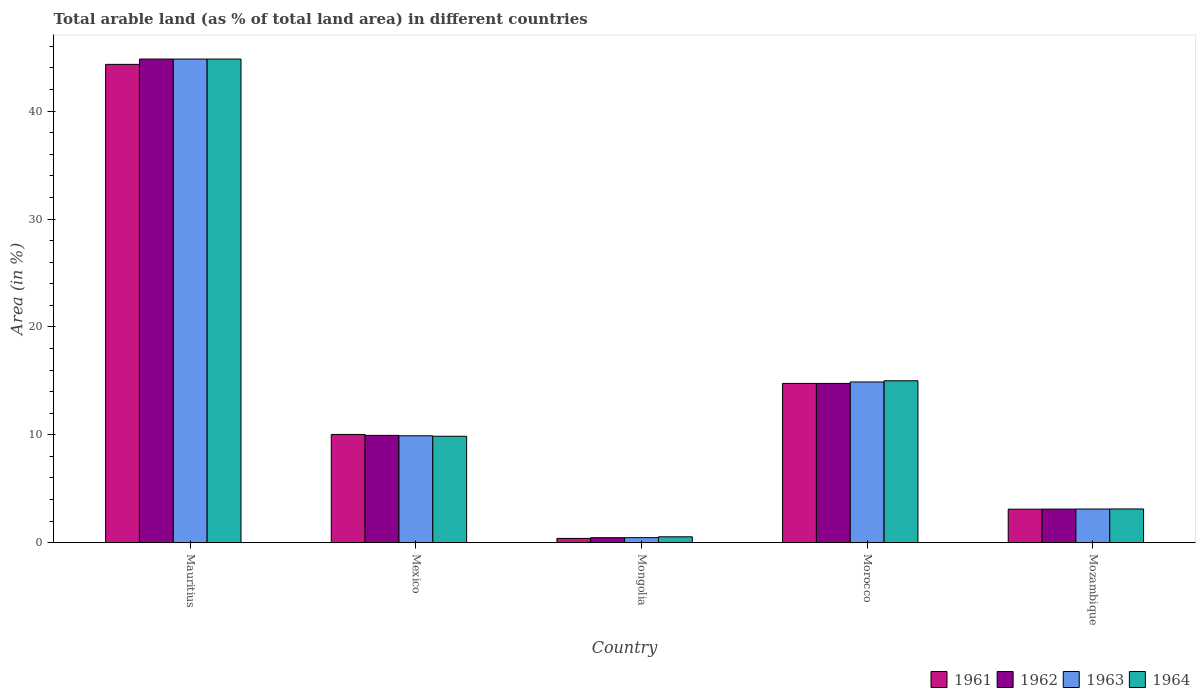Are the number of bars per tick equal to the number of legend labels?
Your answer should be compact. Yes. How many bars are there on the 1st tick from the left?
Offer a terse response. 4. What is the label of the 4th group of bars from the left?
Offer a very short reply. Morocco. What is the percentage of arable land in 1963 in Morocco?
Your answer should be compact. 14.9. Across all countries, what is the maximum percentage of arable land in 1964?
Keep it short and to the point. 44.83. Across all countries, what is the minimum percentage of arable land in 1963?
Offer a very short reply. 0.47. In which country was the percentage of arable land in 1964 maximum?
Give a very brief answer. Mauritius. In which country was the percentage of arable land in 1963 minimum?
Offer a very short reply. Mongolia. What is the total percentage of arable land in 1964 in the graph?
Offer a terse response. 73.38. What is the difference between the percentage of arable land in 1963 in Morocco and that in Mozambique?
Provide a succinct answer. 11.78. What is the difference between the percentage of arable land in 1964 in Mongolia and the percentage of arable land in 1963 in Mauritius?
Give a very brief answer. -44.28. What is the average percentage of arable land in 1962 per country?
Your answer should be compact. 14.62. What is the difference between the percentage of arable land of/in 1961 and percentage of arable land of/in 1962 in Mauritius?
Your response must be concise. -0.49. In how many countries, is the percentage of arable land in 1963 greater than 20 %?
Provide a succinct answer. 1. What is the ratio of the percentage of arable land in 1963 in Mongolia to that in Mozambique?
Provide a short and direct response. 0.15. Is the percentage of arable land in 1961 in Mongolia less than that in Morocco?
Ensure brevity in your answer.  Yes. What is the difference between the highest and the second highest percentage of arable land in 1961?
Offer a terse response. -34.3. What is the difference between the highest and the lowest percentage of arable land in 1961?
Your response must be concise. 43.93. In how many countries, is the percentage of arable land in 1962 greater than the average percentage of arable land in 1962 taken over all countries?
Make the answer very short. 2. What does the 2nd bar from the right in Mexico represents?
Provide a succinct answer. 1963. Is it the case that in every country, the sum of the percentage of arable land in 1963 and percentage of arable land in 1962 is greater than the percentage of arable land in 1964?
Ensure brevity in your answer.  Yes. What is the difference between two consecutive major ticks on the Y-axis?
Your answer should be compact. 10. Does the graph contain grids?
Your response must be concise. No. Where does the legend appear in the graph?
Keep it short and to the point. Bottom right. How many legend labels are there?
Offer a very short reply. 4. How are the legend labels stacked?
Give a very brief answer. Horizontal. What is the title of the graph?
Offer a terse response. Total arable land (as % of total land area) in different countries. What is the label or title of the X-axis?
Give a very brief answer. Country. What is the label or title of the Y-axis?
Your answer should be very brief. Area (in %). What is the Area (in %) in 1961 in Mauritius?
Ensure brevity in your answer.  44.33. What is the Area (in %) in 1962 in Mauritius?
Keep it short and to the point. 44.83. What is the Area (in %) in 1963 in Mauritius?
Provide a short and direct response. 44.83. What is the Area (in %) in 1964 in Mauritius?
Ensure brevity in your answer.  44.83. What is the Area (in %) of 1961 in Mexico?
Provide a short and direct response. 10.03. What is the Area (in %) of 1962 in Mexico?
Provide a succinct answer. 9.95. What is the Area (in %) of 1963 in Mexico?
Offer a terse response. 9.91. What is the Area (in %) of 1964 in Mexico?
Your answer should be compact. 9.87. What is the Area (in %) in 1961 in Mongolia?
Keep it short and to the point. 0.4. What is the Area (in %) of 1962 in Mongolia?
Make the answer very short. 0.47. What is the Area (in %) of 1963 in Mongolia?
Provide a succinct answer. 0.47. What is the Area (in %) of 1964 in Mongolia?
Offer a terse response. 0.55. What is the Area (in %) of 1961 in Morocco?
Give a very brief answer. 14.76. What is the Area (in %) in 1962 in Morocco?
Your answer should be compact. 14.76. What is the Area (in %) of 1963 in Morocco?
Offer a terse response. 14.9. What is the Area (in %) of 1964 in Morocco?
Your answer should be very brief. 15.01. What is the Area (in %) in 1961 in Mozambique?
Your response must be concise. 3.11. What is the Area (in %) of 1962 in Mozambique?
Your answer should be compact. 3.12. What is the Area (in %) of 1963 in Mozambique?
Provide a succinct answer. 3.12. What is the Area (in %) in 1964 in Mozambique?
Provide a short and direct response. 3.13. Across all countries, what is the maximum Area (in %) of 1961?
Your answer should be compact. 44.33. Across all countries, what is the maximum Area (in %) of 1962?
Provide a short and direct response. 44.83. Across all countries, what is the maximum Area (in %) in 1963?
Keep it short and to the point. 44.83. Across all countries, what is the maximum Area (in %) of 1964?
Offer a very short reply. 44.83. Across all countries, what is the minimum Area (in %) of 1961?
Ensure brevity in your answer.  0.4. Across all countries, what is the minimum Area (in %) of 1962?
Offer a very short reply. 0.47. Across all countries, what is the minimum Area (in %) of 1963?
Make the answer very short. 0.47. Across all countries, what is the minimum Area (in %) in 1964?
Provide a succinct answer. 0.55. What is the total Area (in %) of 1961 in the graph?
Ensure brevity in your answer.  72.64. What is the total Area (in %) of 1962 in the graph?
Ensure brevity in your answer.  73.12. What is the total Area (in %) in 1963 in the graph?
Offer a terse response. 73.23. What is the total Area (in %) of 1964 in the graph?
Ensure brevity in your answer.  73.38. What is the difference between the Area (in %) in 1961 in Mauritius and that in Mexico?
Offer a very short reply. 34.3. What is the difference between the Area (in %) of 1962 in Mauritius and that in Mexico?
Your response must be concise. 34.88. What is the difference between the Area (in %) of 1963 in Mauritius and that in Mexico?
Your answer should be compact. 34.92. What is the difference between the Area (in %) of 1964 in Mauritius and that in Mexico?
Provide a short and direct response. 34.96. What is the difference between the Area (in %) in 1961 in Mauritius and that in Mongolia?
Provide a succinct answer. 43.93. What is the difference between the Area (in %) of 1962 in Mauritius and that in Mongolia?
Offer a very short reply. 44.36. What is the difference between the Area (in %) in 1963 in Mauritius and that in Mongolia?
Your answer should be very brief. 44.36. What is the difference between the Area (in %) of 1964 in Mauritius and that in Mongolia?
Offer a very short reply. 44.28. What is the difference between the Area (in %) of 1961 in Mauritius and that in Morocco?
Provide a succinct answer. 29.57. What is the difference between the Area (in %) of 1962 in Mauritius and that in Morocco?
Offer a very short reply. 30.06. What is the difference between the Area (in %) in 1963 in Mauritius and that in Morocco?
Provide a succinct answer. 29.93. What is the difference between the Area (in %) of 1964 in Mauritius and that in Morocco?
Offer a very short reply. 29.82. What is the difference between the Area (in %) of 1961 in Mauritius and that in Mozambique?
Keep it short and to the point. 41.23. What is the difference between the Area (in %) in 1962 in Mauritius and that in Mozambique?
Provide a short and direct response. 41.71. What is the difference between the Area (in %) of 1963 in Mauritius and that in Mozambique?
Provide a short and direct response. 41.71. What is the difference between the Area (in %) of 1964 in Mauritius and that in Mozambique?
Provide a succinct answer. 41.7. What is the difference between the Area (in %) in 1961 in Mexico and that in Mongolia?
Provide a short and direct response. 9.63. What is the difference between the Area (in %) of 1962 in Mexico and that in Mongolia?
Provide a short and direct response. 9.48. What is the difference between the Area (in %) of 1963 in Mexico and that in Mongolia?
Provide a succinct answer. 9.44. What is the difference between the Area (in %) in 1964 in Mexico and that in Mongolia?
Your response must be concise. 9.32. What is the difference between the Area (in %) of 1961 in Mexico and that in Morocco?
Your answer should be very brief. -4.73. What is the difference between the Area (in %) of 1962 in Mexico and that in Morocco?
Give a very brief answer. -4.82. What is the difference between the Area (in %) of 1963 in Mexico and that in Morocco?
Offer a very short reply. -4.99. What is the difference between the Area (in %) in 1964 in Mexico and that in Morocco?
Provide a succinct answer. -5.14. What is the difference between the Area (in %) in 1961 in Mexico and that in Mozambique?
Your answer should be compact. 6.93. What is the difference between the Area (in %) of 1962 in Mexico and that in Mozambique?
Provide a succinct answer. 6.83. What is the difference between the Area (in %) of 1963 in Mexico and that in Mozambique?
Ensure brevity in your answer.  6.79. What is the difference between the Area (in %) of 1964 in Mexico and that in Mozambique?
Your response must be concise. 6.74. What is the difference between the Area (in %) in 1961 in Mongolia and that in Morocco?
Your response must be concise. -14.36. What is the difference between the Area (in %) of 1962 in Mongolia and that in Morocco?
Your answer should be compact. -14.3. What is the difference between the Area (in %) in 1963 in Mongolia and that in Morocco?
Your response must be concise. -14.43. What is the difference between the Area (in %) in 1964 in Mongolia and that in Morocco?
Provide a succinct answer. -14.46. What is the difference between the Area (in %) of 1961 in Mongolia and that in Mozambique?
Ensure brevity in your answer.  -2.71. What is the difference between the Area (in %) in 1962 in Mongolia and that in Mozambique?
Provide a succinct answer. -2.65. What is the difference between the Area (in %) of 1963 in Mongolia and that in Mozambique?
Provide a short and direct response. -2.65. What is the difference between the Area (in %) in 1964 in Mongolia and that in Mozambique?
Provide a succinct answer. -2.58. What is the difference between the Area (in %) of 1961 in Morocco and that in Mozambique?
Provide a succinct answer. 11.66. What is the difference between the Area (in %) in 1962 in Morocco and that in Mozambique?
Keep it short and to the point. 11.65. What is the difference between the Area (in %) in 1963 in Morocco and that in Mozambique?
Your answer should be compact. 11.78. What is the difference between the Area (in %) of 1964 in Morocco and that in Mozambique?
Provide a succinct answer. 11.88. What is the difference between the Area (in %) in 1961 in Mauritius and the Area (in %) in 1962 in Mexico?
Keep it short and to the point. 34.39. What is the difference between the Area (in %) in 1961 in Mauritius and the Area (in %) in 1963 in Mexico?
Your answer should be very brief. 34.43. What is the difference between the Area (in %) of 1961 in Mauritius and the Area (in %) of 1964 in Mexico?
Your answer should be very brief. 34.47. What is the difference between the Area (in %) of 1962 in Mauritius and the Area (in %) of 1963 in Mexico?
Make the answer very short. 34.92. What is the difference between the Area (in %) of 1962 in Mauritius and the Area (in %) of 1964 in Mexico?
Make the answer very short. 34.96. What is the difference between the Area (in %) of 1963 in Mauritius and the Area (in %) of 1964 in Mexico?
Provide a short and direct response. 34.96. What is the difference between the Area (in %) of 1961 in Mauritius and the Area (in %) of 1962 in Mongolia?
Your answer should be compact. 43.87. What is the difference between the Area (in %) in 1961 in Mauritius and the Area (in %) in 1963 in Mongolia?
Your answer should be very brief. 43.87. What is the difference between the Area (in %) of 1961 in Mauritius and the Area (in %) of 1964 in Mongolia?
Offer a terse response. 43.79. What is the difference between the Area (in %) in 1962 in Mauritius and the Area (in %) in 1963 in Mongolia?
Offer a very short reply. 44.36. What is the difference between the Area (in %) of 1962 in Mauritius and the Area (in %) of 1964 in Mongolia?
Provide a short and direct response. 44.28. What is the difference between the Area (in %) in 1963 in Mauritius and the Area (in %) in 1964 in Mongolia?
Offer a terse response. 44.28. What is the difference between the Area (in %) in 1961 in Mauritius and the Area (in %) in 1962 in Morocco?
Your response must be concise. 29.57. What is the difference between the Area (in %) in 1961 in Mauritius and the Area (in %) in 1963 in Morocco?
Provide a short and direct response. 29.44. What is the difference between the Area (in %) in 1961 in Mauritius and the Area (in %) in 1964 in Morocco?
Your answer should be compact. 29.32. What is the difference between the Area (in %) of 1962 in Mauritius and the Area (in %) of 1963 in Morocco?
Give a very brief answer. 29.93. What is the difference between the Area (in %) in 1962 in Mauritius and the Area (in %) in 1964 in Morocco?
Provide a short and direct response. 29.82. What is the difference between the Area (in %) in 1963 in Mauritius and the Area (in %) in 1964 in Morocco?
Give a very brief answer. 29.82. What is the difference between the Area (in %) of 1961 in Mauritius and the Area (in %) of 1962 in Mozambique?
Offer a terse response. 41.22. What is the difference between the Area (in %) in 1961 in Mauritius and the Area (in %) in 1963 in Mozambique?
Your response must be concise. 41.21. What is the difference between the Area (in %) of 1961 in Mauritius and the Area (in %) of 1964 in Mozambique?
Keep it short and to the point. 41.21. What is the difference between the Area (in %) in 1962 in Mauritius and the Area (in %) in 1963 in Mozambique?
Provide a succinct answer. 41.71. What is the difference between the Area (in %) in 1962 in Mauritius and the Area (in %) in 1964 in Mozambique?
Provide a succinct answer. 41.7. What is the difference between the Area (in %) of 1963 in Mauritius and the Area (in %) of 1964 in Mozambique?
Keep it short and to the point. 41.7. What is the difference between the Area (in %) in 1961 in Mexico and the Area (in %) in 1962 in Mongolia?
Your response must be concise. 9.57. What is the difference between the Area (in %) of 1961 in Mexico and the Area (in %) of 1963 in Mongolia?
Your response must be concise. 9.57. What is the difference between the Area (in %) in 1961 in Mexico and the Area (in %) in 1964 in Mongolia?
Offer a very short reply. 9.49. What is the difference between the Area (in %) in 1962 in Mexico and the Area (in %) in 1963 in Mongolia?
Your response must be concise. 9.48. What is the difference between the Area (in %) in 1962 in Mexico and the Area (in %) in 1964 in Mongolia?
Offer a terse response. 9.4. What is the difference between the Area (in %) in 1963 in Mexico and the Area (in %) in 1964 in Mongolia?
Your answer should be compact. 9.36. What is the difference between the Area (in %) of 1961 in Mexico and the Area (in %) of 1962 in Morocco?
Provide a short and direct response. -4.73. What is the difference between the Area (in %) of 1961 in Mexico and the Area (in %) of 1963 in Morocco?
Provide a short and direct response. -4.86. What is the difference between the Area (in %) in 1961 in Mexico and the Area (in %) in 1964 in Morocco?
Provide a short and direct response. -4.98. What is the difference between the Area (in %) of 1962 in Mexico and the Area (in %) of 1963 in Morocco?
Offer a terse response. -4.95. What is the difference between the Area (in %) in 1962 in Mexico and the Area (in %) in 1964 in Morocco?
Your answer should be compact. -5.06. What is the difference between the Area (in %) in 1963 in Mexico and the Area (in %) in 1964 in Morocco?
Make the answer very short. -5.1. What is the difference between the Area (in %) of 1961 in Mexico and the Area (in %) of 1962 in Mozambique?
Make the answer very short. 6.92. What is the difference between the Area (in %) in 1961 in Mexico and the Area (in %) in 1963 in Mozambique?
Your answer should be very brief. 6.91. What is the difference between the Area (in %) in 1961 in Mexico and the Area (in %) in 1964 in Mozambique?
Offer a terse response. 6.91. What is the difference between the Area (in %) in 1962 in Mexico and the Area (in %) in 1963 in Mozambique?
Offer a very short reply. 6.83. What is the difference between the Area (in %) in 1962 in Mexico and the Area (in %) in 1964 in Mozambique?
Your response must be concise. 6.82. What is the difference between the Area (in %) in 1963 in Mexico and the Area (in %) in 1964 in Mozambique?
Offer a very short reply. 6.78. What is the difference between the Area (in %) in 1961 in Mongolia and the Area (in %) in 1962 in Morocco?
Provide a short and direct response. -14.36. What is the difference between the Area (in %) of 1961 in Mongolia and the Area (in %) of 1963 in Morocco?
Keep it short and to the point. -14.5. What is the difference between the Area (in %) in 1961 in Mongolia and the Area (in %) in 1964 in Morocco?
Your response must be concise. -14.61. What is the difference between the Area (in %) in 1962 in Mongolia and the Area (in %) in 1963 in Morocco?
Ensure brevity in your answer.  -14.43. What is the difference between the Area (in %) of 1962 in Mongolia and the Area (in %) of 1964 in Morocco?
Keep it short and to the point. -14.54. What is the difference between the Area (in %) in 1963 in Mongolia and the Area (in %) in 1964 in Morocco?
Offer a very short reply. -14.54. What is the difference between the Area (in %) of 1961 in Mongolia and the Area (in %) of 1962 in Mozambique?
Your answer should be compact. -2.71. What is the difference between the Area (in %) of 1961 in Mongolia and the Area (in %) of 1963 in Mozambique?
Keep it short and to the point. -2.72. What is the difference between the Area (in %) of 1961 in Mongolia and the Area (in %) of 1964 in Mozambique?
Provide a short and direct response. -2.73. What is the difference between the Area (in %) in 1962 in Mongolia and the Area (in %) in 1963 in Mozambique?
Offer a very short reply. -2.66. What is the difference between the Area (in %) of 1962 in Mongolia and the Area (in %) of 1964 in Mozambique?
Your response must be concise. -2.66. What is the difference between the Area (in %) in 1963 in Mongolia and the Area (in %) in 1964 in Mozambique?
Provide a short and direct response. -2.66. What is the difference between the Area (in %) of 1961 in Morocco and the Area (in %) of 1962 in Mozambique?
Offer a very short reply. 11.65. What is the difference between the Area (in %) of 1961 in Morocco and the Area (in %) of 1963 in Mozambique?
Offer a terse response. 11.64. What is the difference between the Area (in %) of 1961 in Morocco and the Area (in %) of 1964 in Mozambique?
Make the answer very short. 11.64. What is the difference between the Area (in %) in 1962 in Morocco and the Area (in %) in 1963 in Mozambique?
Make the answer very short. 11.64. What is the difference between the Area (in %) in 1962 in Morocco and the Area (in %) in 1964 in Mozambique?
Your response must be concise. 11.64. What is the difference between the Area (in %) of 1963 in Morocco and the Area (in %) of 1964 in Mozambique?
Give a very brief answer. 11.77. What is the average Area (in %) in 1961 per country?
Your answer should be compact. 14.53. What is the average Area (in %) in 1962 per country?
Give a very brief answer. 14.62. What is the average Area (in %) of 1963 per country?
Offer a very short reply. 14.65. What is the average Area (in %) in 1964 per country?
Ensure brevity in your answer.  14.68. What is the difference between the Area (in %) in 1961 and Area (in %) in 1962 in Mauritius?
Your answer should be compact. -0.49. What is the difference between the Area (in %) of 1961 and Area (in %) of 1963 in Mauritius?
Your response must be concise. -0.49. What is the difference between the Area (in %) in 1961 and Area (in %) in 1964 in Mauritius?
Offer a very short reply. -0.49. What is the difference between the Area (in %) of 1963 and Area (in %) of 1964 in Mauritius?
Provide a short and direct response. 0. What is the difference between the Area (in %) in 1961 and Area (in %) in 1962 in Mexico?
Keep it short and to the point. 0.09. What is the difference between the Area (in %) of 1961 and Area (in %) of 1963 in Mexico?
Your answer should be very brief. 0.13. What is the difference between the Area (in %) in 1961 and Area (in %) in 1964 in Mexico?
Give a very brief answer. 0.17. What is the difference between the Area (in %) of 1962 and Area (in %) of 1963 in Mexico?
Provide a succinct answer. 0.04. What is the difference between the Area (in %) in 1962 and Area (in %) in 1964 in Mexico?
Provide a short and direct response. 0.08. What is the difference between the Area (in %) of 1963 and Area (in %) of 1964 in Mexico?
Provide a short and direct response. 0.04. What is the difference between the Area (in %) in 1961 and Area (in %) in 1962 in Mongolia?
Give a very brief answer. -0.06. What is the difference between the Area (in %) of 1961 and Area (in %) of 1963 in Mongolia?
Make the answer very short. -0.07. What is the difference between the Area (in %) of 1961 and Area (in %) of 1964 in Mongolia?
Provide a succinct answer. -0.15. What is the difference between the Area (in %) in 1962 and Area (in %) in 1963 in Mongolia?
Your answer should be very brief. -0. What is the difference between the Area (in %) in 1962 and Area (in %) in 1964 in Mongolia?
Ensure brevity in your answer.  -0.08. What is the difference between the Area (in %) in 1963 and Area (in %) in 1964 in Mongolia?
Make the answer very short. -0.08. What is the difference between the Area (in %) in 1961 and Area (in %) in 1963 in Morocco?
Your answer should be very brief. -0.13. What is the difference between the Area (in %) in 1961 and Area (in %) in 1964 in Morocco?
Provide a succinct answer. -0.25. What is the difference between the Area (in %) of 1962 and Area (in %) of 1963 in Morocco?
Your answer should be very brief. -0.13. What is the difference between the Area (in %) in 1962 and Area (in %) in 1964 in Morocco?
Ensure brevity in your answer.  -0.25. What is the difference between the Area (in %) of 1963 and Area (in %) of 1964 in Morocco?
Provide a short and direct response. -0.11. What is the difference between the Area (in %) of 1961 and Area (in %) of 1962 in Mozambique?
Make the answer very short. -0.01. What is the difference between the Area (in %) in 1961 and Area (in %) in 1963 in Mozambique?
Offer a very short reply. -0.01. What is the difference between the Area (in %) of 1961 and Area (in %) of 1964 in Mozambique?
Keep it short and to the point. -0.02. What is the difference between the Area (in %) of 1962 and Area (in %) of 1963 in Mozambique?
Provide a short and direct response. -0.01. What is the difference between the Area (in %) of 1962 and Area (in %) of 1964 in Mozambique?
Keep it short and to the point. -0.01. What is the difference between the Area (in %) in 1963 and Area (in %) in 1964 in Mozambique?
Give a very brief answer. -0.01. What is the ratio of the Area (in %) of 1961 in Mauritius to that in Mexico?
Your response must be concise. 4.42. What is the ratio of the Area (in %) of 1962 in Mauritius to that in Mexico?
Your response must be concise. 4.51. What is the ratio of the Area (in %) of 1963 in Mauritius to that in Mexico?
Your response must be concise. 4.52. What is the ratio of the Area (in %) in 1964 in Mauritius to that in Mexico?
Keep it short and to the point. 4.54. What is the ratio of the Area (in %) of 1961 in Mauritius to that in Mongolia?
Provide a short and direct response. 110.38. What is the ratio of the Area (in %) in 1962 in Mauritius to that in Mongolia?
Your answer should be compact. 96.19. What is the ratio of the Area (in %) of 1963 in Mauritius to that in Mongolia?
Your answer should be very brief. 95.53. What is the ratio of the Area (in %) of 1964 in Mauritius to that in Mongolia?
Your answer should be very brief. 81.93. What is the ratio of the Area (in %) of 1961 in Mauritius to that in Morocco?
Ensure brevity in your answer.  3. What is the ratio of the Area (in %) in 1962 in Mauritius to that in Morocco?
Your answer should be very brief. 3.04. What is the ratio of the Area (in %) in 1963 in Mauritius to that in Morocco?
Keep it short and to the point. 3.01. What is the ratio of the Area (in %) of 1964 in Mauritius to that in Morocco?
Provide a short and direct response. 2.99. What is the ratio of the Area (in %) of 1961 in Mauritius to that in Mozambique?
Provide a succinct answer. 14.27. What is the ratio of the Area (in %) of 1962 in Mauritius to that in Mozambique?
Provide a short and direct response. 14.39. What is the ratio of the Area (in %) in 1963 in Mauritius to that in Mozambique?
Offer a terse response. 14.36. What is the ratio of the Area (in %) in 1964 in Mauritius to that in Mozambique?
Provide a short and direct response. 14.33. What is the ratio of the Area (in %) in 1961 in Mexico to that in Mongolia?
Ensure brevity in your answer.  24.98. What is the ratio of the Area (in %) in 1962 in Mexico to that in Mongolia?
Provide a short and direct response. 21.35. What is the ratio of the Area (in %) in 1963 in Mexico to that in Mongolia?
Ensure brevity in your answer.  21.11. What is the ratio of the Area (in %) in 1964 in Mexico to that in Mongolia?
Provide a succinct answer. 18.03. What is the ratio of the Area (in %) of 1961 in Mexico to that in Morocco?
Ensure brevity in your answer.  0.68. What is the ratio of the Area (in %) of 1962 in Mexico to that in Morocco?
Offer a very short reply. 0.67. What is the ratio of the Area (in %) in 1963 in Mexico to that in Morocco?
Ensure brevity in your answer.  0.67. What is the ratio of the Area (in %) of 1964 in Mexico to that in Morocco?
Provide a short and direct response. 0.66. What is the ratio of the Area (in %) in 1961 in Mexico to that in Mozambique?
Ensure brevity in your answer.  3.23. What is the ratio of the Area (in %) in 1962 in Mexico to that in Mozambique?
Offer a very short reply. 3.19. What is the ratio of the Area (in %) of 1963 in Mexico to that in Mozambique?
Your answer should be very brief. 3.17. What is the ratio of the Area (in %) of 1964 in Mexico to that in Mozambique?
Provide a short and direct response. 3.15. What is the ratio of the Area (in %) in 1961 in Mongolia to that in Morocco?
Provide a succinct answer. 0.03. What is the ratio of the Area (in %) of 1962 in Mongolia to that in Morocco?
Ensure brevity in your answer.  0.03. What is the ratio of the Area (in %) of 1963 in Mongolia to that in Morocco?
Provide a succinct answer. 0.03. What is the ratio of the Area (in %) in 1964 in Mongolia to that in Morocco?
Your answer should be very brief. 0.04. What is the ratio of the Area (in %) in 1961 in Mongolia to that in Mozambique?
Make the answer very short. 0.13. What is the ratio of the Area (in %) of 1962 in Mongolia to that in Mozambique?
Your answer should be compact. 0.15. What is the ratio of the Area (in %) in 1963 in Mongolia to that in Mozambique?
Keep it short and to the point. 0.15. What is the ratio of the Area (in %) of 1964 in Mongolia to that in Mozambique?
Provide a succinct answer. 0.17. What is the ratio of the Area (in %) in 1961 in Morocco to that in Mozambique?
Your answer should be compact. 4.75. What is the ratio of the Area (in %) in 1962 in Morocco to that in Mozambique?
Your answer should be compact. 4.74. What is the ratio of the Area (in %) of 1963 in Morocco to that in Mozambique?
Provide a short and direct response. 4.77. What is the ratio of the Area (in %) in 1964 in Morocco to that in Mozambique?
Your answer should be very brief. 4.8. What is the difference between the highest and the second highest Area (in %) in 1961?
Ensure brevity in your answer.  29.57. What is the difference between the highest and the second highest Area (in %) of 1962?
Offer a very short reply. 30.06. What is the difference between the highest and the second highest Area (in %) of 1963?
Offer a terse response. 29.93. What is the difference between the highest and the second highest Area (in %) of 1964?
Give a very brief answer. 29.82. What is the difference between the highest and the lowest Area (in %) of 1961?
Offer a terse response. 43.93. What is the difference between the highest and the lowest Area (in %) of 1962?
Your answer should be compact. 44.36. What is the difference between the highest and the lowest Area (in %) in 1963?
Offer a very short reply. 44.36. What is the difference between the highest and the lowest Area (in %) in 1964?
Give a very brief answer. 44.28. 